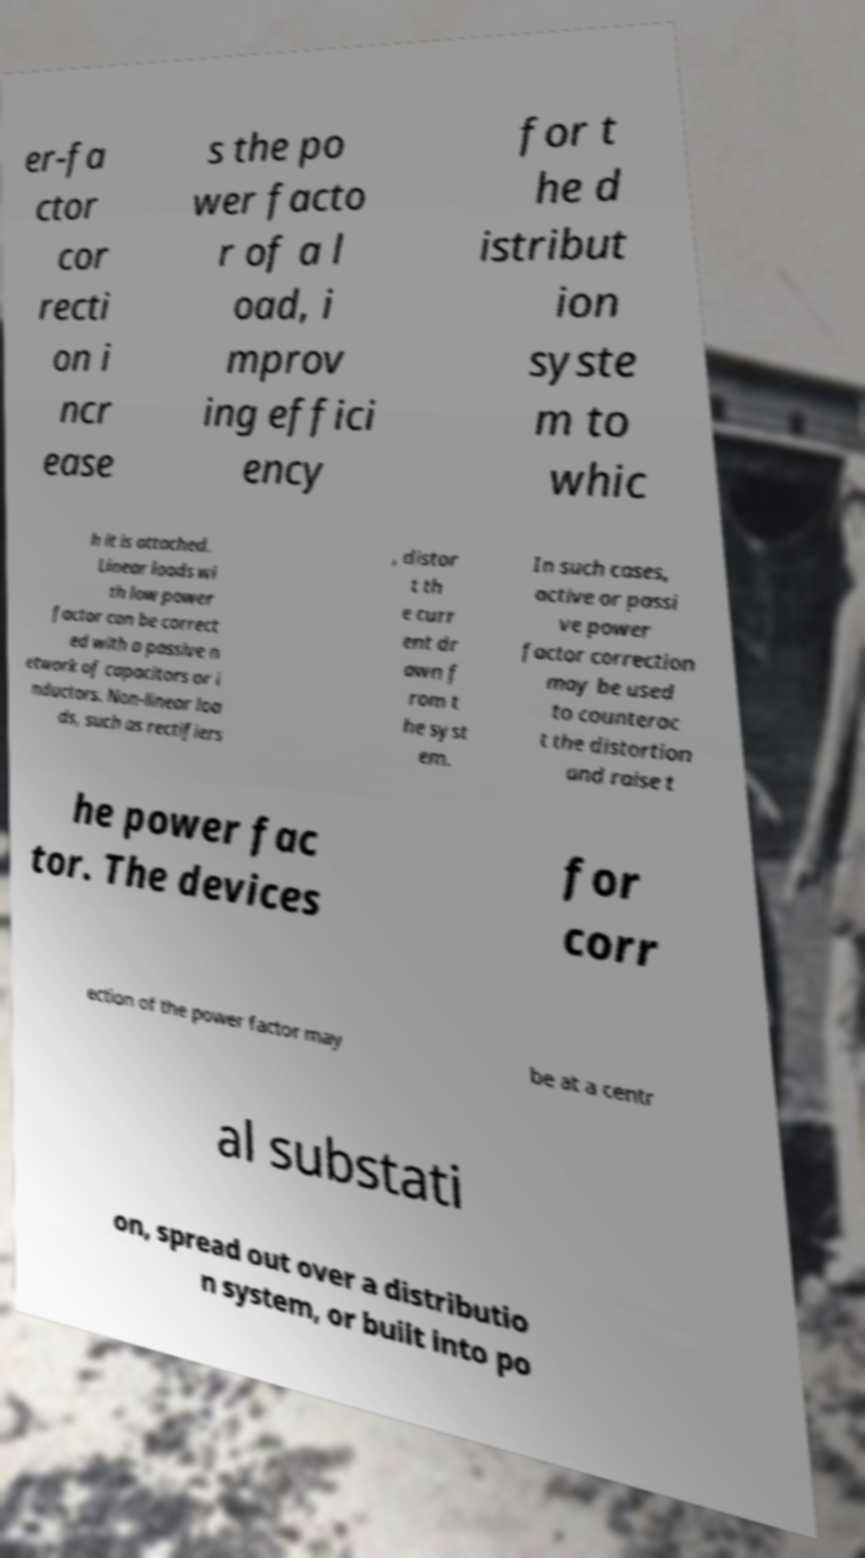Please identify and transcribe the text found in this image. er-fa ctor cor recti on i ncr ease s the po wer facto r of a l oad, i mprov ing effici ency for t he d istribut ion syste m to whic h it is attached. Linear loads wi th low power factor can be correct ed with a passive n etwork of capacitors or i nductors. Non-linear loa ds, such as rectifiers , distor t th e curr ent dr awn f rom t he syst em. In such cases, active or passi ve power factor correction may be used to counterac t the distortion and raise t he power fac tor. The devices for corr ection of the power factor may be at a centr al substati on, spread out over a distributio n system, or built into po 